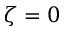<formula> <loc_0><loc_0><loc_500><loc_500>\zeta = 0</formula> 